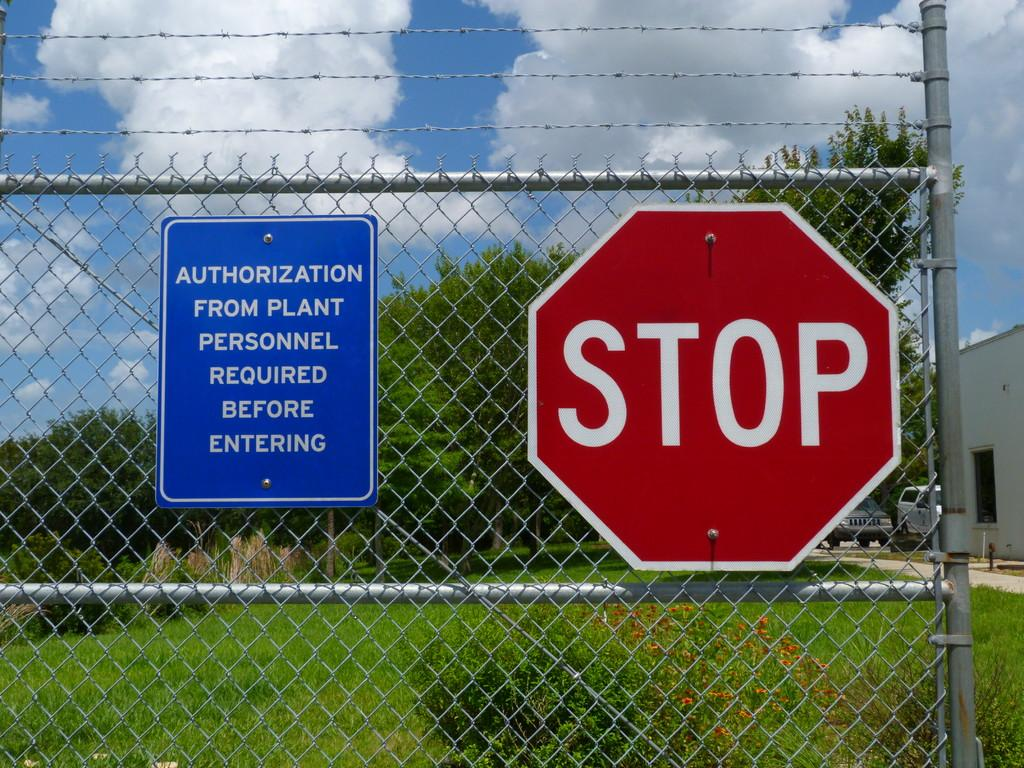<image>
Summarize the visual content of the image. a stop sign that is on a fence outside 